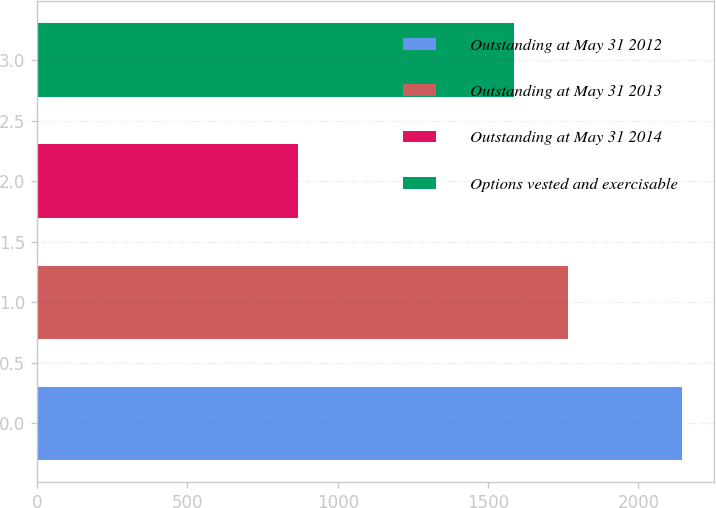Convert chart to OTSL. <chart><loc_0><loc_0><loc_500><loc_500><bar_chart><fcel>Outstanding at May 31 2012<fcel>Outstanding at May 31 2013<fcel>Outstanding at May 31 2014<fcel>Options vested and exercisable<nl><fcel>2145<fcel>1765<fcel>867<fcel>1586<nl></chart> 